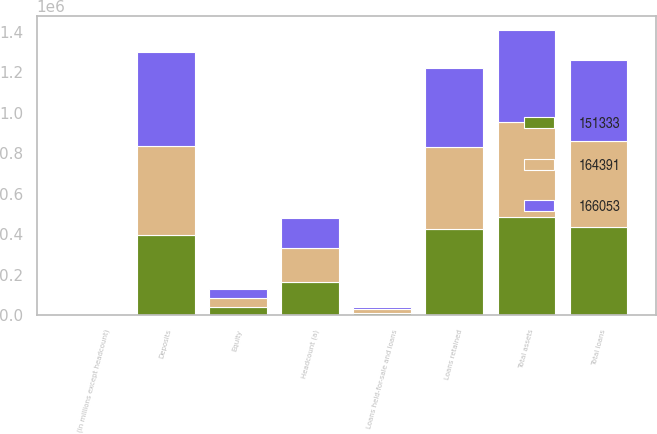Convert chart. <chart><loc_0><loc_0><loc_500><loc_500><stacked_bar_chart><ecel><fcel>(in millions except headcount)<fcel>Total assets<fcel>Loans retained<fcel>Loans held-for-sale and loans<fcel>Total loans<fcel>Deposits<fcel>Equity<fcel>Headcount (a)<nl><fcel>166053<fcel>2013<fcel>452929<fcel>393351<fcel>7772<fcel>401123<fcel>464412<fcel>46000<fcel>151333<nl><fcel>164391<fcel>2012<fcel>467282<fcel>402963<fcel>18801<fcel>421764<fcel>438517<fcel>43000<fcel>164391<nl><fcel>151333<fcel>2011<fcel>486697<fcel>425581<fcel>12796<fcel>438377<fcel>397868<fcel>41000<fcel>166053<nl></chart> 